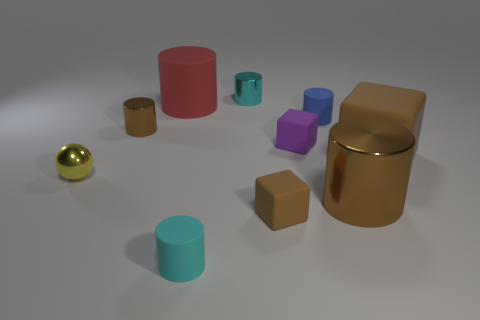There is another cylinder that is the same color as the big shiny cylinder; what is it made of?
Provide a succinct answer. Metal. Do the large block and the tiny yellow thing have the same material?
Give a very brief answer. No. Is the number of tiny brown shiny cylinders to the left of the ball less than the number of tiny metallic objects?
Offer a very short reply. Yes. There is a brown matte block that is in front of the shiny ball; is its size the same as the small sphere?
Your answer should be very brief. Yes. What number of large brown things are behind the big brown cylinder and on the left side of the large brown block?
Provide a short and direct response. 0. What size is the brown cylinder right of the metal cylinder on the left side of the cyan matte object?
Make the answer very short. Large. Is the number of brown cylinders on the right side of the tiny brown block less than the number of shiny objects that are on the right side of the tiny yellow object?
Ensure brevity in your answer.  Yes. There is a tiny cylinder that is left of the red matte cylinder; does it have the same color as the block that is in front of the yellow metallic ball?
Your answer should be very brief. Yes. What material is the object that is both behind the small blue object and right of the large red rubber thing?
Give a very brief answer. Metal. Are any large brown matte blocks visible?
Your response must be concise. Yes. 